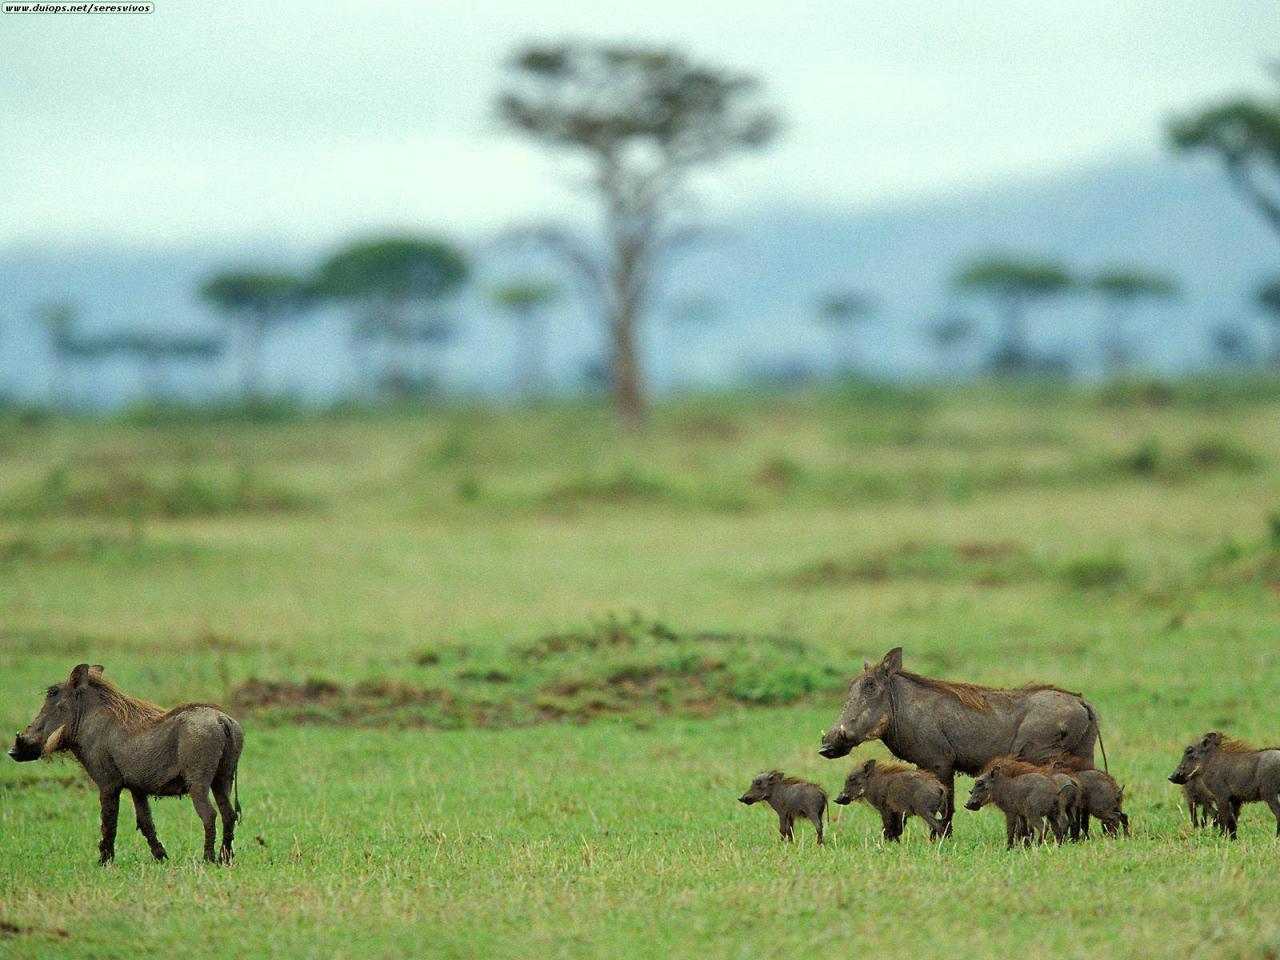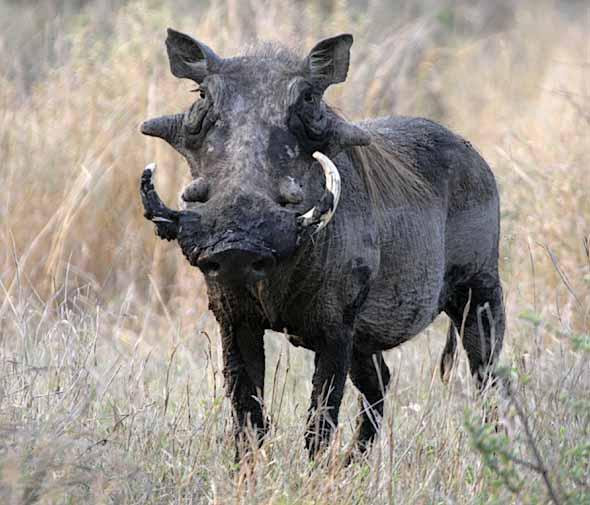The first image is the image on the left, the second image is the image on the right. Analyze the images presented: Is the assertion "At least one warthog is near water." valid? Answer yes or no. No. The first image is the image on the left, the second image is the image on the right. Given the left and right images, does the statement "The image on the left contains no more than two wart hogs." hold true? Answer yes or no. No. 